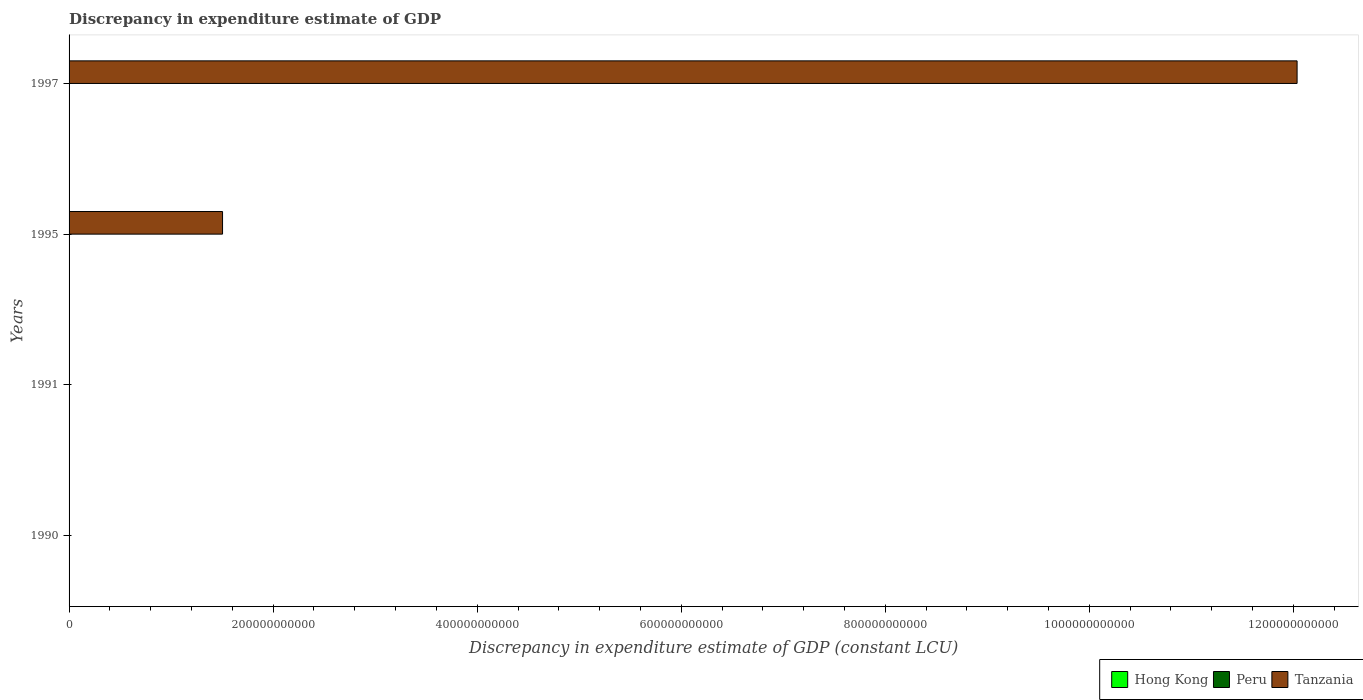Are the number of bars per tick equal to the number of legend labels?
Make the answer very short. No. How many bars are there on the 1st tick from the bottom?
Give a very brief answer. 1. What is the discrepancy in expenditure estimate of GDP in Hong Kong in 1995?
Ensure brevity in your answer.  0. Across all years, what is the minimum discrepancy in expenditure estimate of GDP in Hong Kong?
Give a very brief answer. 0. What is the total discrepancy in expenditure estimate of GDP in Tanzania in the graph?
Keep it short and to the point. 1.35e+12. What is the difference between the discrepancy in expenditure estimate of GDP in Tanzania in 1995 and that in 1997?
Offer a very short reply. -1.05e+12. What is the difference between the discrepancy in expenditure estimate of GDP in Tanzania in 1990 and the discrepancy in expenditure estimate of GDP in Peru in 1997?
Offer a very short reply. -100. What is the average discrepancy in expenditure estimate of GDP in Peru per year?
Make the answer very short. 50. In the year 1997, what is the difference between the discrepancy in expenditure estimate of GDP in Tanzania and discrepancy in expenditure estimate of GDP in Peru?
Make the answer very short. 1.20e+12. In how many years, is the discrepancy in expenditure estimate of GDP in Peru greater than 360000000000 LCU?
Offer a very short reply. 0. What is the difference between the highest and the lowest discrepancy in expenditure estimate of GDP in Tanzania?
Offer a terse response. 1.20e+12. In how many years, is the discrepancy in expenditure estimate of GDP in Hong Kong greater than the average discrepancy in expenditure estimate of GDP in Hong Kong taken over all years?
Ensure brevity in your answer.  0. Is the sum of the discrepancy in expenditure estimate of GDP in Tanzania in 1995 and 1997 greater than the maximum discrepancy in expenditure estimate of GDP in Peru across all years?
Your response must be concise. Yes. Are all the bars in the graph horizontal?
Provide a short and direct response. Yes. How many years are there in the graph?
Keep it short and to the point. 4. What is the difference between two consecutive major ticks on the X-axis?
Keep it short and to the point. 2.00e+11. Does the graph contain any zero values?
Give a very brief answer. Yes. How many legend labels are there?
Your answer should be very brief. 3. How are the legend labels stacked?
Ensure brevity in your answer.  Horizontal. What is the title of the graph?
Provide a short and direct response. Discrepancy in expenditure estimate of GDP. Does "Curacao" appear as one of the legend labels in the graph?
Offer a terse response. No. What is the label or title of the X-axis?
Keep it short and to the point. Discrepancy in expenditure estimate of GDP (constant LCU). What is the Discrepancy in expenditure estimate of GDP (constant LCU) in Peru in 1990?
Provide a succinct answer. 100. What is the Discrepancy in expenditure estimate of GDP (constant LCU) of Tanzania in 1990?
Offer a terse response. 0. What is the Discrepancy in expenditure estimate of GDP (constant LCU) of Peru in 1991?
Provide a short and direct response. 0. What is the Discrepancy in expenditure estimate of GDP (constant LCU) of Peru in 1995?
Keep it short and to the point. 0. What is the Discrepancy in expenditure estimate of GDP (constant LCU) in Tanzania in 1995?
Your answer should be very brief. 1.50e+11. What is the Discrepancy in expenditure estimate of GDP (constant LCU) in Hong Kong in 1997?
Offer a terse response. 0. What is the Discrepancy in expenditure estimate of GDP (constant LCU) in Tanzania in 1997?
Provide a short and direct response. 1.20e+12. Across all years, what is the maximum Discrepancy in expenditure estimate of GDP (constant LCU) of Tanzania?
Give a very brief answer. 1.20e+12. What is the total Discrepancy in expenditure estimate of GDP (constant LCU) of Hong Kong in the graph?
Give a very brief answer. 0. What is the total Discrepancy in expenditure estimate of GDP (constant LCU) of Tanzania in the graph?
Offer a very short reply. 1.35e+12. What is the difference between the Discrepancy in expenditure estimate of GDP (constant LCU) in Peru in 1990 and that in 1997?
Offer a terse response. 0. What is the difference between the Discrepancy in expenditure estimate of GDP (constant LCU) of Tanzania in 1995 and that in 1997?
Provide a succinct answer. -1.05e+12. What is the difference between the Discrepancy in expenditure estimate of GDP (constant LCU) of Peru in 1990 and the Discrepancy in expenditure estimate of GDP (constant LCU) of Tanzania in 1995?
Make the answer very short. -1.50e+11. What is the difference between the Discrepancy in expenditure estimate of GDP (constant LCU) in Peru in 1990 and the Discrepancy in expenditure estimate of GDP (constant LCU) in Tanzania in 1997?
Give a very brief answer. -1.20e+12. What is the average Discrepancy in expenditure estimate of GDP (constant LCU) of Hong Kong per year?
Keep it short and to the point. 0. What is the average Discrepancy in expenditure estimate of GDP (constant LCU) in Tanzania per year?
Your response must be concise. 3.39e+11. In the year 1997, what is the difference between the Discrepancy in expenditure estimate of GDP (constant LCU) of Peru and Discrepancy in expenditure estimate of GDP (constant LCU) of Tanzania?
Offer a very short reply. -1.20e+12. What is the ratio of the Discrepancy in expenditure estimate of GDP (constant LCU) of Tanzania in 1995 to that in 1997?
Your answer should be compact. 0.12. What is the difference between the highest and the lowest Discrepancy in expenditure estimate of GDP (constant LCU) of Tanzania?
Your response must be concise. 1.20e+12. 